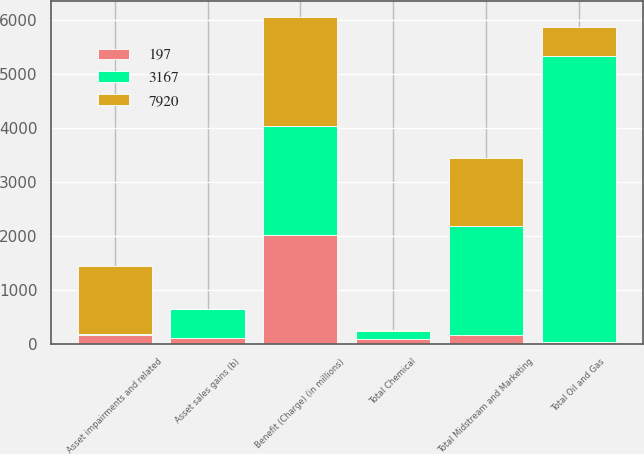Convert chart. <chart><loc_0><loc_0><loc_500><loc_500><stacked_bar_chart><ecel><fcel>Benefit (Charge) (in millions)<fcel>Asset sales gains (b)<fcel>Asset impairments and related<fcel>Total Oil and Gas<fcel>Total Chemical<fcel>Total Midstream and Marketing<nl><fcel>197<fcel>2016<fcel>107<fcel>160<fcel>36<fcel>88<fcel>160<nl><fcel>7920<fcel>2015<fcel>10<fcel>1259<fcel>531<fcel>23<fcel>1259<nl><fcel>3167<fcel>2014<fcel>531<fcel>31<fcel>5301<fcel>149<fcel>2015<nl></chart> 